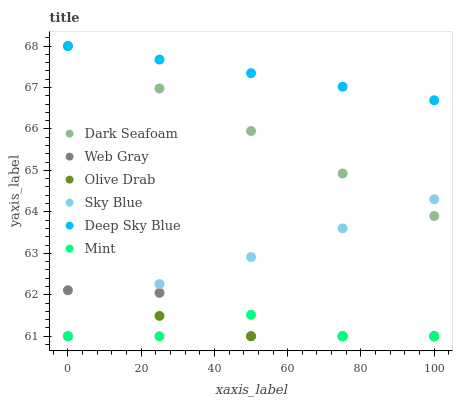Does Olive Drab have the minimum area under the curve?
Answer yes or no. Yes. Does Deep Sky Blue have the maximum area under the curve?
Answer yes or no. Yes. Does Dark Seafoam have the minimum area under the curve?
Answer yes or no. No. Does Dark Seafoam have the maximum area under the curve?
Answer yes or no. No. Is Dark Seafoam the smoothest?
Answer yes or no. Yes. Is Mint the roughest?
Answer yes or no. Yes. Is Deep Sky Blue the smoothest?
Answer yes or no. No. Is Deep Sky Blue the roughest?
Answer yes or no. No. Does Web Gray have the lowest value?
Answer yes or no. Yes. Does Dark Seafoam have the lowest value?
Answer yes or no. No. Does Deep Sky Blue have the highest value?
Answer yes or no. Yes. Does Sky Blue have the highest value?
Answer yes or no. No. Is Mint less than Deep Sky Blue?
Answer yes or no. Yes. Is Deep Sky Blue greater than Web Gray?
Answer yes or no. Yes. Does Mint intersect Olive Drab?
Answer yes or no. Yes. Is Mint less than Olive Drab?
Answer yes or no. No. Is Mint greater than Olive Drab?
Answer yes or no. No. Does Mint intersect Deep Sky Blue?
Answer yes or no. No. 